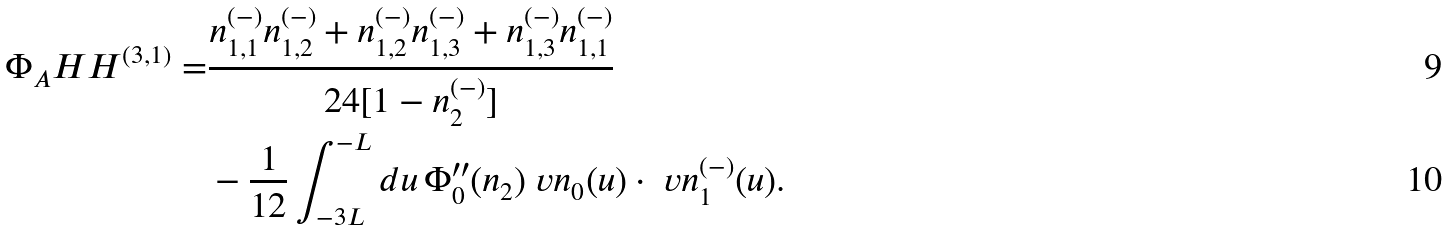Convert formula to latex. <formula><loc_0><loc_0><loc_500><loc_500>\Phi _ { A } H H ^ { ( 3 , 1 ) } = & \frac { n _ { 1 , 1 } ^ { ( - ) } n _ { 1 , 2 } ^ { ( - ) } + n _ { 1 , 2 } ^ { ( - ) } n _ { 1 , 3 } ^ { ( - ) } + n _ { 1 , 3 } ^ { ( - ) } n _ { 1 , 1 } ^ { ( - ) } } { 2 4 [ 1 - n _ { 2 } ^ { ( - ) } ] } \\ & - \frac { 1 } { 1 2 } \int _ { - 3 L } ^ { - L } d u \, \Phi ^ { \prime \prime } _ { 0 } ( n _ { 2 } ) \ v n _ { 0 } ( u ) \cdot \ v n _ { 1 } ^ { ( - ) } ( u ) .</formula> 